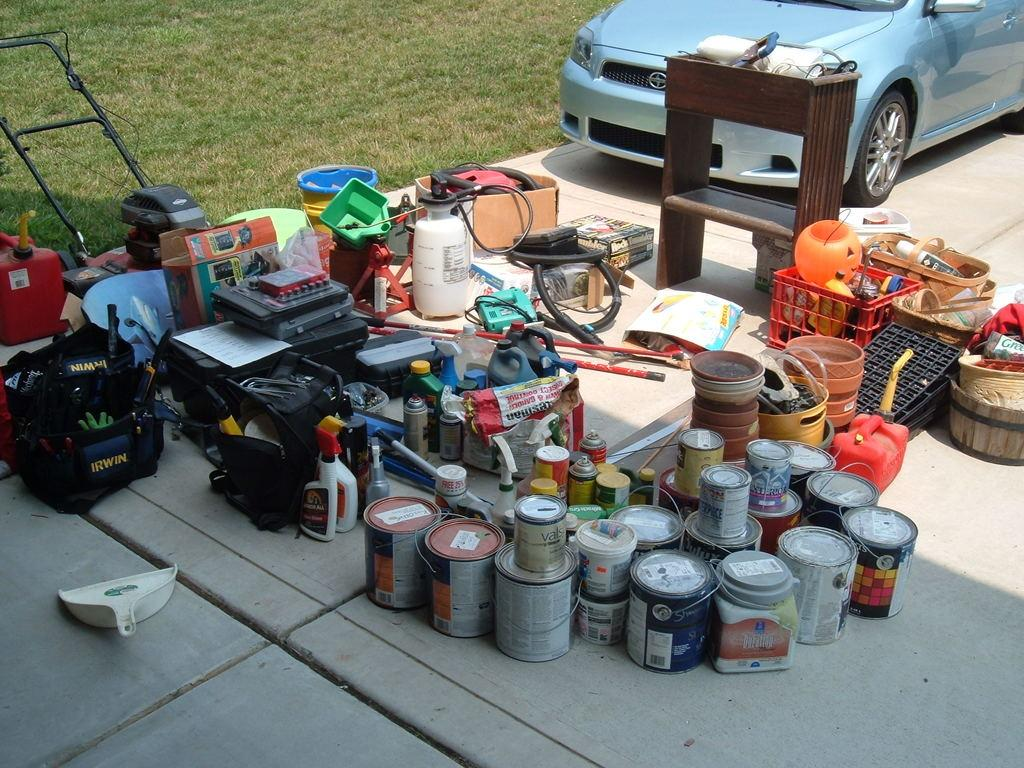What type of containers can be seen in the image? There are baskets, paint buckets, and spray bottles in the image. What other items are present in the image? There are bags, a machine, a cardboard box, and various unspecified objects on a table. What is the setting of the image? There is grass visible in the image, suggesting an outdoor setting. What type of vehicle is in the image? There is a vehicle in the image, but its specific type is not mentioned. What type of boot is being used to apply oil to the machine in the image? There is no boot or oil present in the image. The machine and other objects are not being used or manipulated in any way. 